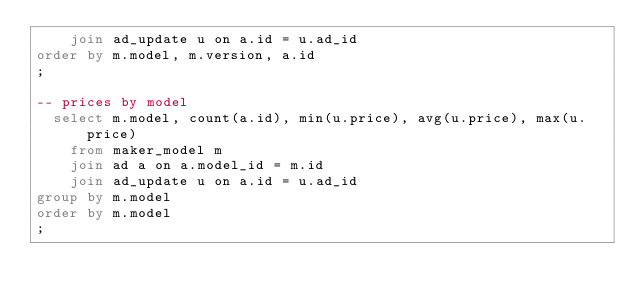<code> <loc_0><loc_0><loc_500><loc_500><_SQL_>    join ad_update u on a.id = u.ad_id
order by m.model, m.version, a.id
;

-- prices by model
  select m.model, count(a.id), min(u.price), avg(u.price), max(u.price)
    from maker_model m
    join ad a on a.model_id = m.id
    join ad_update u on a.id = u.ad_id
group by m.model
order by m.model
;
</code> 